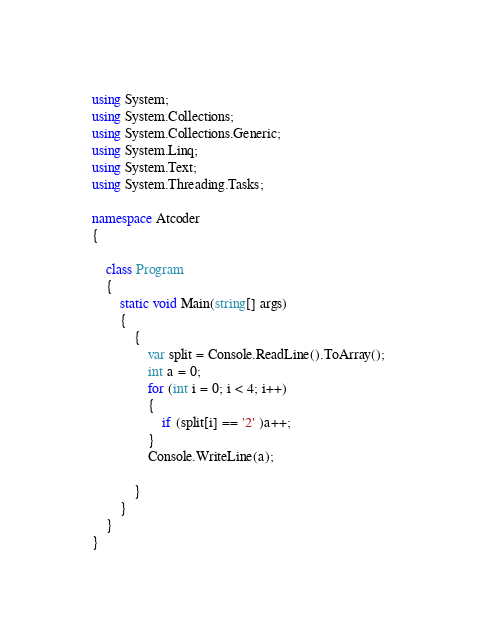<code> <loc_0><loc_0><loc_500><loc_500><_C#_>using System;
using System.Collections;
using System.Collections.Generic;
using System.Linq;
using System.Text;
using System.Threading.Tasks;

namespace Atcoder
{

    class Program
    {
        static void Main(string[] args)
        {
            {
                var split = Console.ReadLine().ToArray();
                int a = 0;
                for (int i = 0; i < 4; i++)
                {
                    if (split[i] == '2' )a++;
                }
                Console.WriteLine(a);

            }
        }
    }
}
</code> 